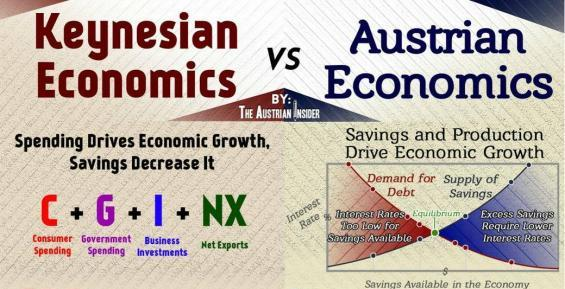Which two economic theories are compared in the document?
Answer the question with a short phrase. Keynesian economic, Austrian Economics What according to the Keynesian economics paves way for economic growth, spending, saving, or production? spending Which two activities drive economic growth in Austrian economics? Savings and Production 